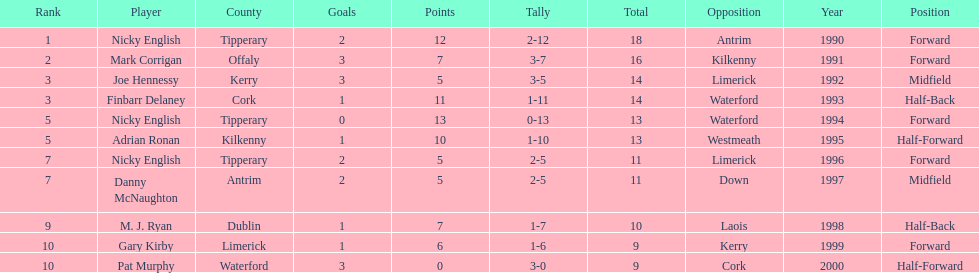What is the first name on the list? Nicky English. 